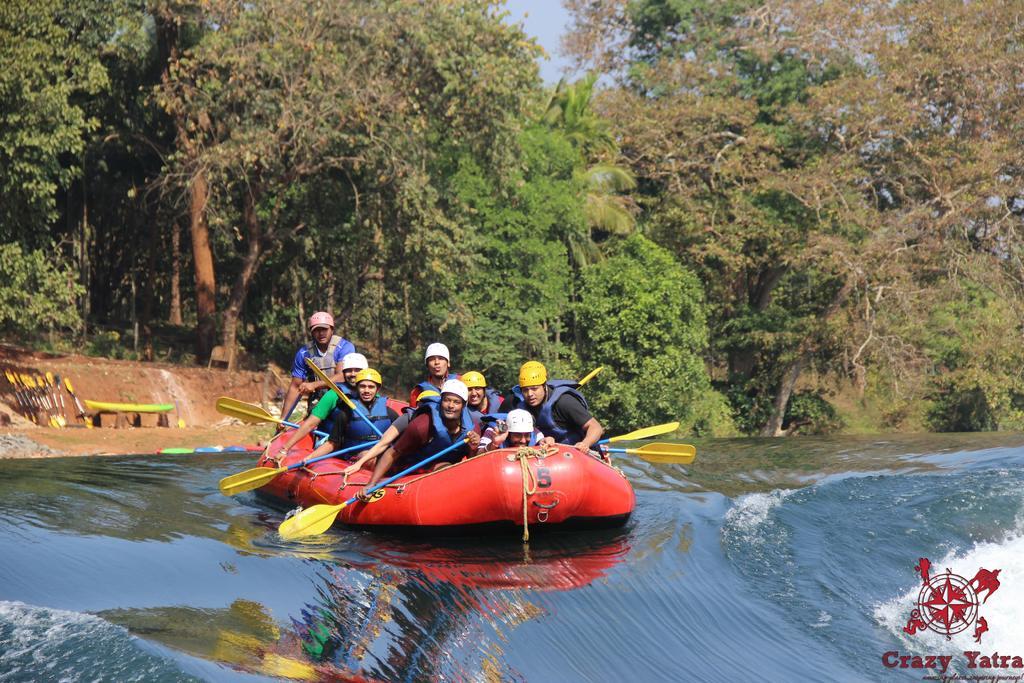Could you give a brief overview of what you see in this image? In this image I can see the water and on the surface of the water I can see a boat which is red in color. On the boat I can see few persons wearing helmets and holding paddles in their hands. In the background I can see the ground, few trees and the sky. 